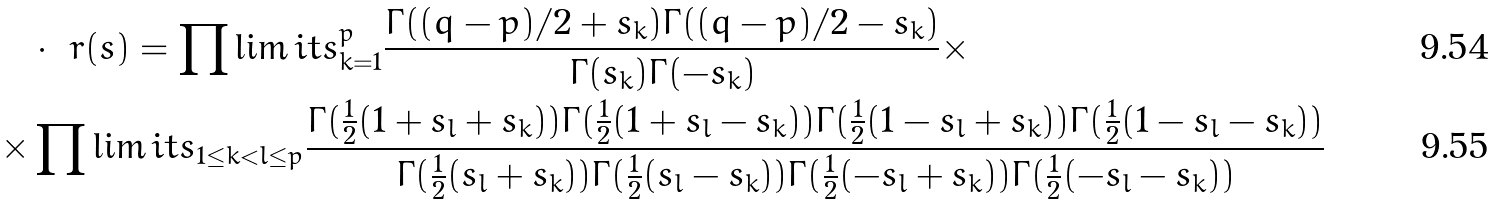<formula> <loc_0><loc_0><loc_500><loc_500>& \cdot \ r ( s ) = \prod \lim i t s _ { k = 1 } ^ { p } \frac { \Gamma ( ( q - p ) / 2 + s _ { k } ) \Gamma ( ( q - p ) / 2 - s _ { k } ) } { \Gamma ( s _ { k } ) \Gamma ( - s _ { k } ) } \times \\ \times & \prod \lim i t s _ { 1 \leq k < l \leq p } \frac { \Gamma ( \frac { 1 } { 2 } ( 1 + s _ { l } + s _ { k } ) ) \Gamma ( \frac { 1 } { 2 } ( 1 + s _ { l } - s _ { k } ) ) \Gamma ( \frac { 1 } { 2 } ( 1 - s _ { l } + s _ { k } ) ) \Gamma ( \frac { 1 } { 2 } ( 1 - s _ { l } - s _ { k } ) ) } { \Gamma ( \frac { 1 } { 2 } ( s _ { l } + s _ { k } ) ) \Gamma ( \frac { 1 } { 2 } ( s _ { l } - s _ { k } ) ) \Gamma ( \frac { 1 } { 2 } ( - s _ { l } + s _ { k } ) ) \Gamma ( \frac { 1 } { 2 } ( - s _ { l } - s _ { k } ) ) }</formula> 